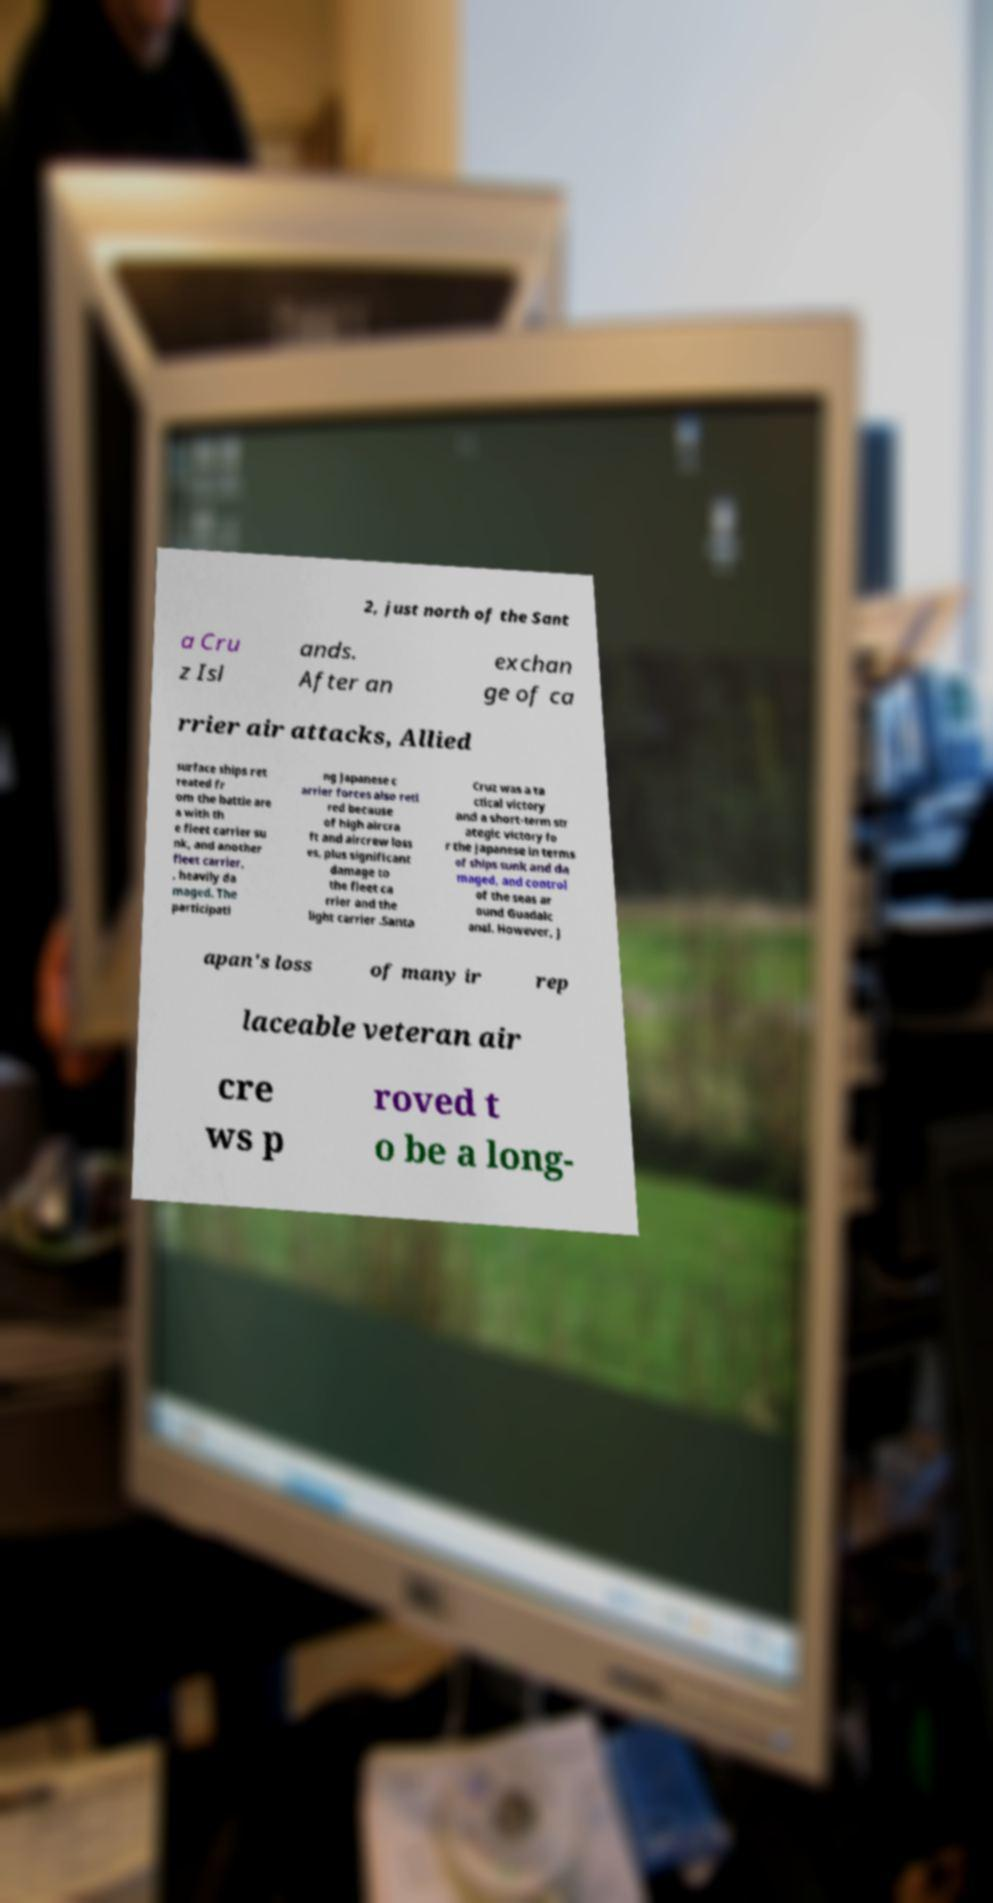Can you accurately transcribe the text from the provided image for me? 2, just north of the Sant a Cru z Isl ands. After an exchan ge of ca rrier air attacks, Allied surface ships ret reated fr om the battle are a with th e fleet carrier su nk, and another fleet carrier, , heavily da maged. The participati ng Japanese c arrier forces also reti red because of high aircra ft and aircrew loss es, plus significant damage to the fleet ca rrier and the light carrier .Santa Cruz was a ta ctical victory and a short-term str ategic victory fo r the Japanese in terms of ships sunk and da maged, and control of the seas ar ound Guadalc anal. However, J apan's loss of many ir rep laceable veteran air cre ws p roved t o be a long- 